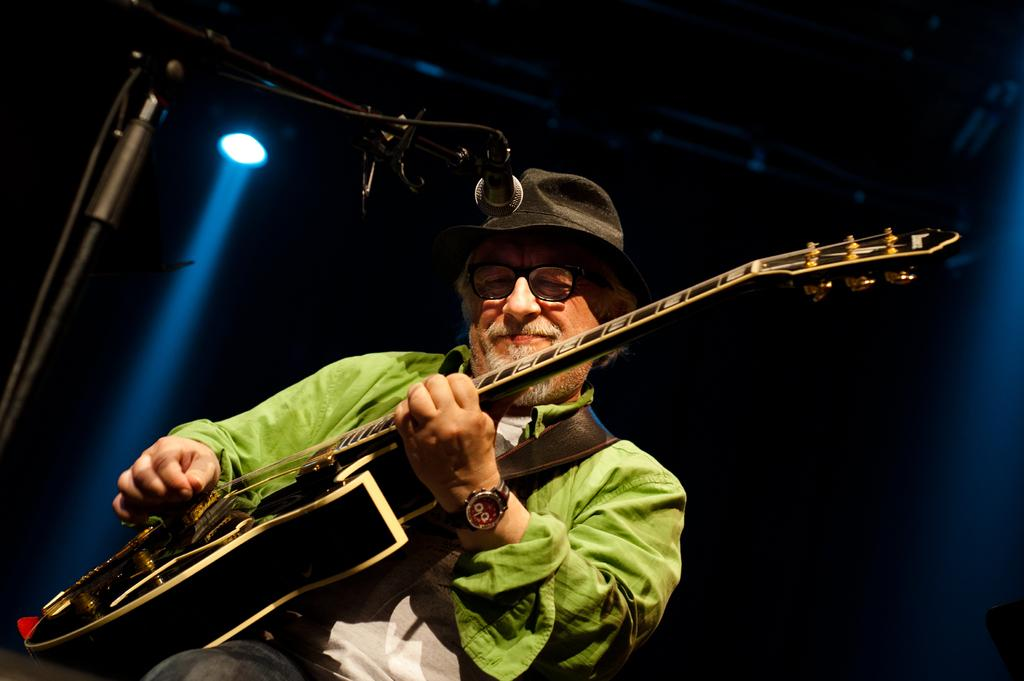What is the person in the image doing? The person in the image is holding a guitar. What accessory is the person wearing on their wrist? The person is wearing a wrist watch. What type of headwear is the person wearing? The person is wearing a black hat. What type of yam is the person holding in the image? There is no yam present in the image; the person is holding a guitar. 